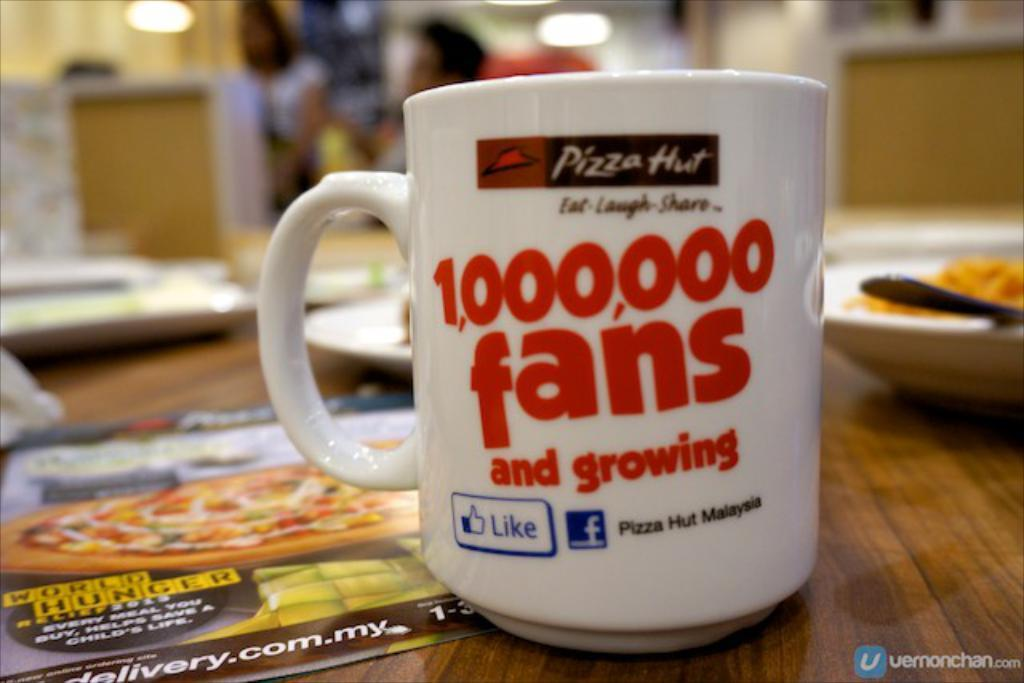<image>
Write a terse but informative summary of the picture. A Pizza Hut logo can be seen on a mug. 